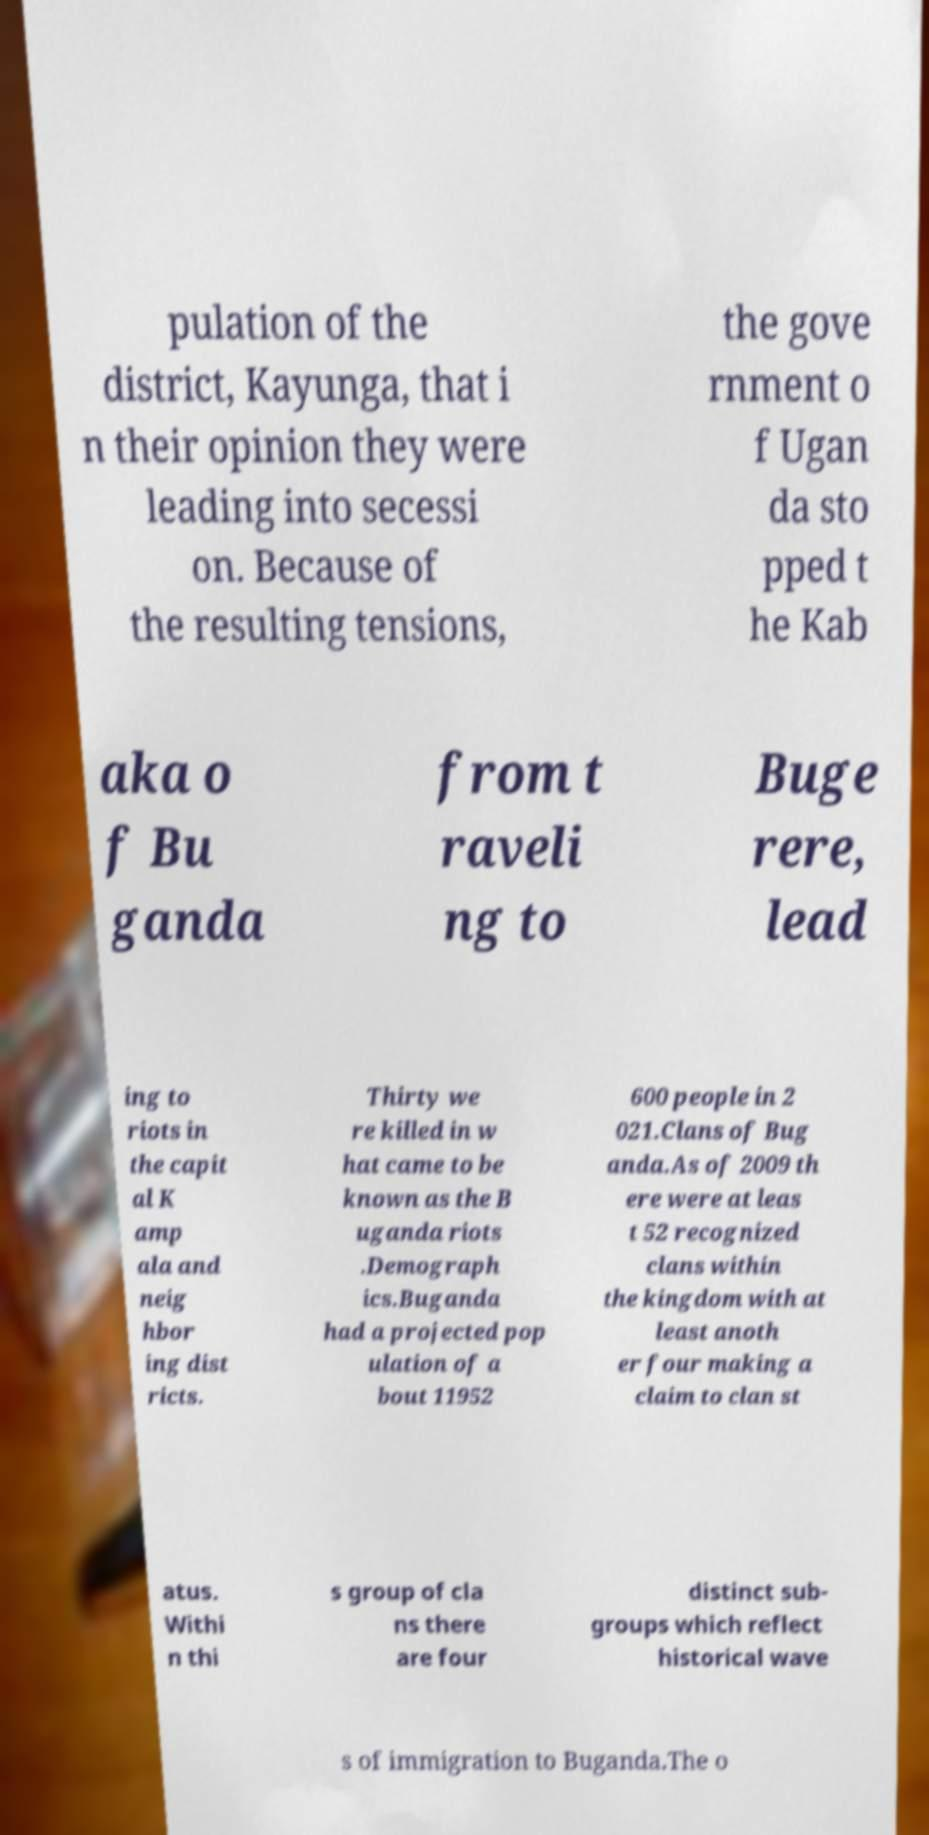For documentation purposes, I need the text within this image transcribed. Could you provide that? pulation of the district, Kayunga, that i n their opinion they were leading into secessi on. Because of the resulting tensions, the gove rnment o f Ugan da sto pped t he Kab aka o f Bu ganda from t raveli ng to Buge rere, lead ing to riots in the capit al K amp ala and neig hbor ing dist ricts. Thirty we re killed in w hat came to be known as the B uganda riots .Demograph ics.Buganda had a projected pop ulation of a bout 11952 600 people in 2 021.Clans of Bug anda.As of 2009 th ere were at leas t 52 recognized clans within the kingdom with at least anoth er four making a claim to clan st atus. Withi n thi s group of cla ns there are four distinct sub- groups which reflect historical wave s of immigration to Buganda.The o 